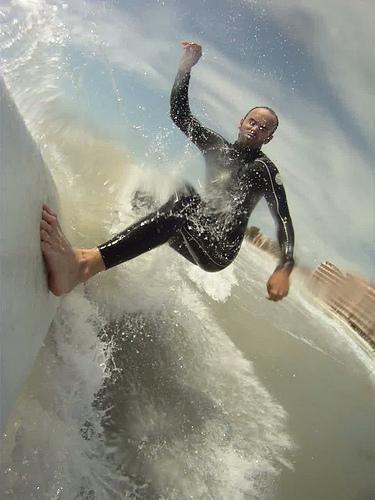How many surfboards can be seen?
Give a very brief answer. 1. 